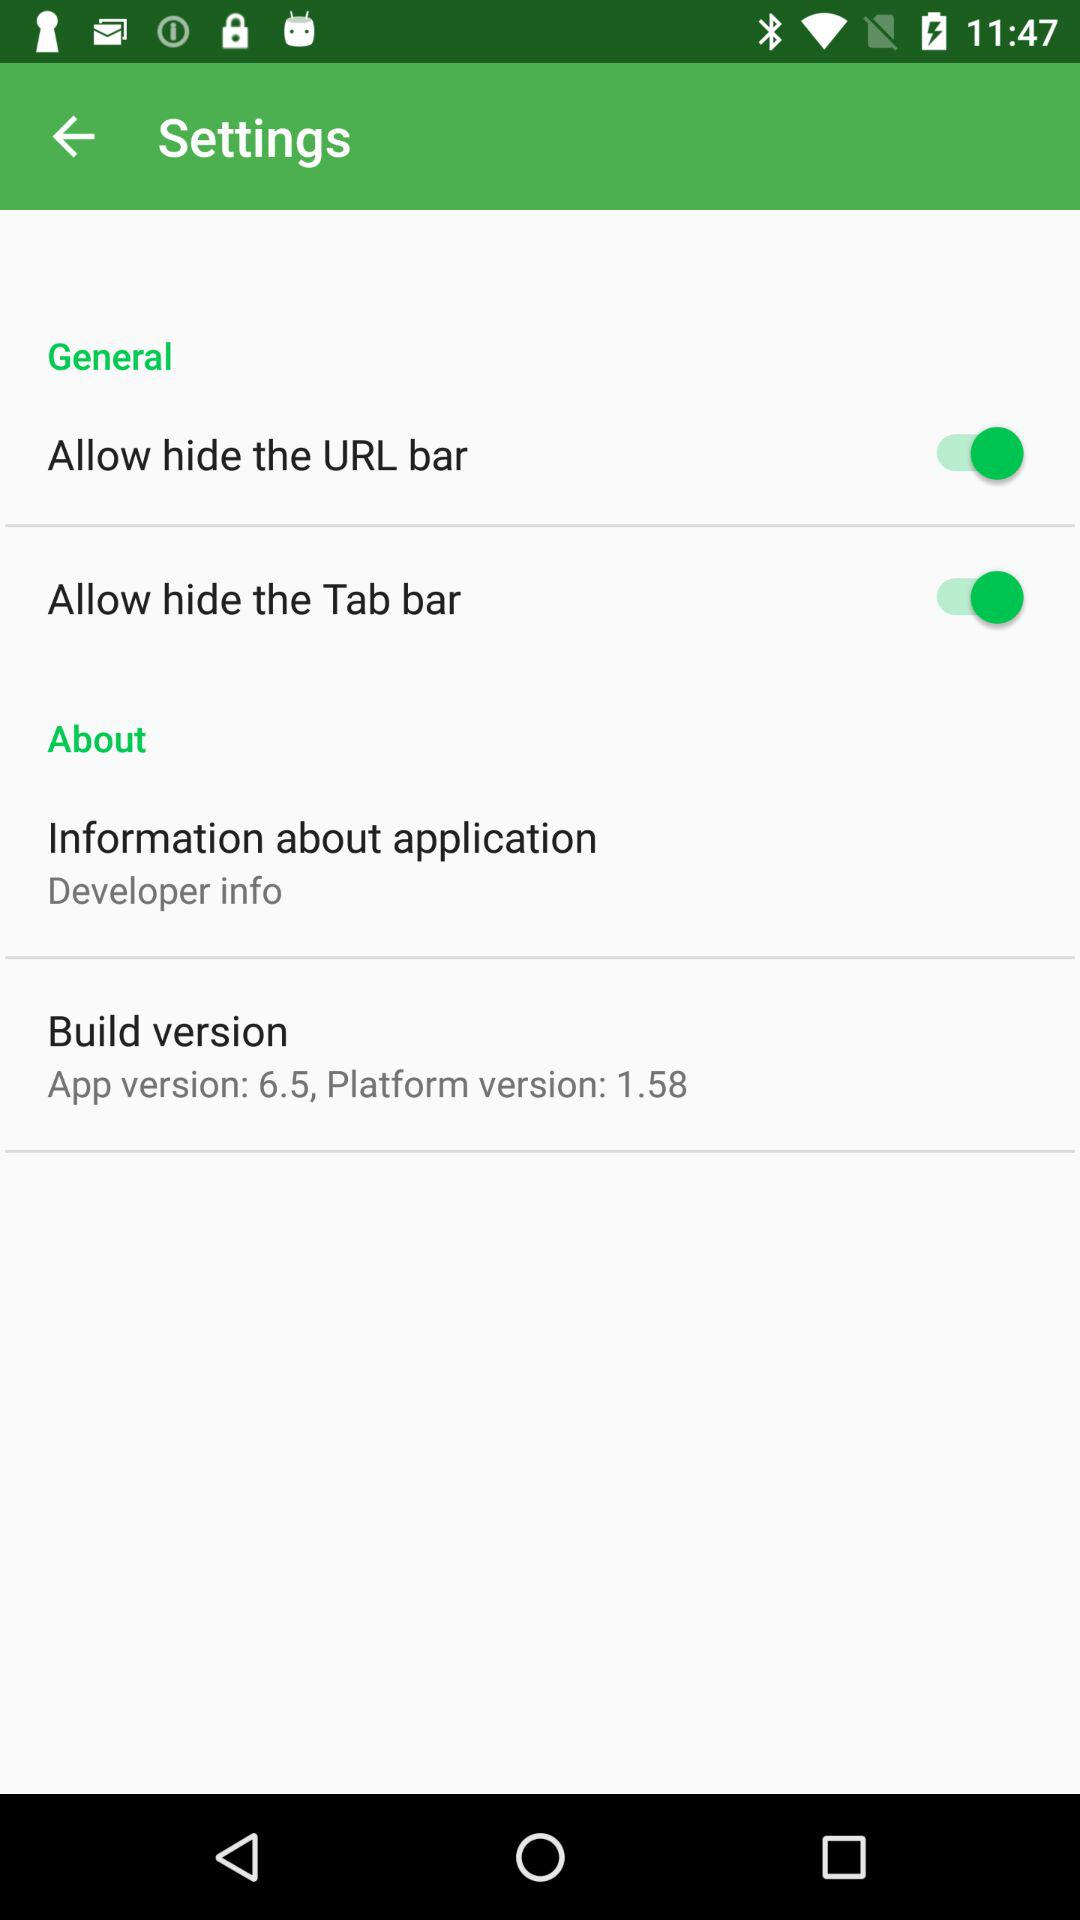What are the setting options that are enabled? The enabled options are "Allow hide the URL bar" and "Allow hide the Tab bar". 